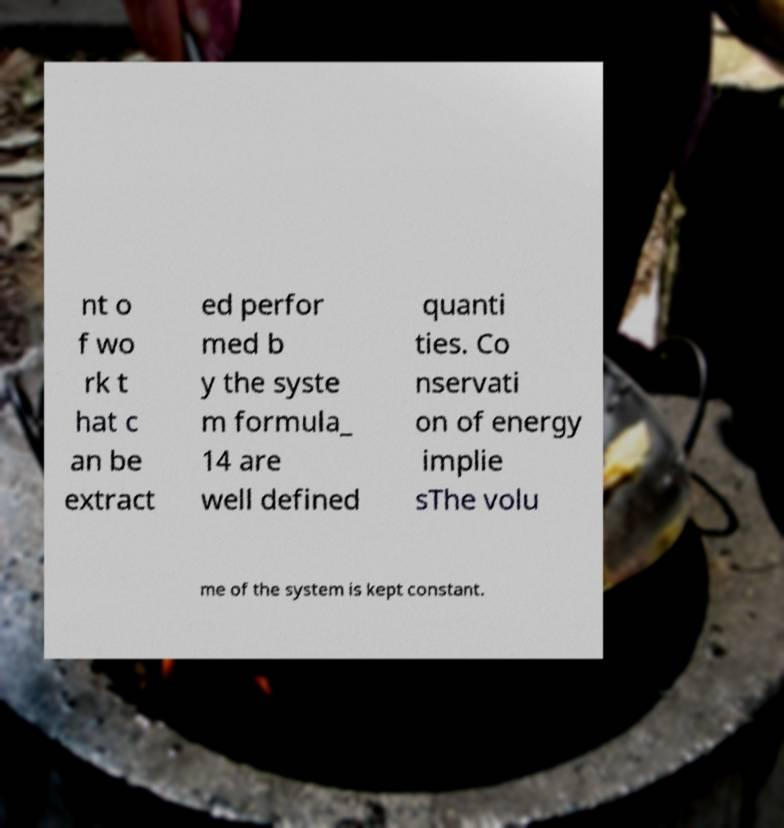Can you read and provide the text displayed in the image?This photo seems to have some interesting text. Can you extract and type it out for me? nt o f wo rk t hat c an be extract ed perfor med b y the syste m formula_ 14 are well defined quanti ties. Co nservati on of energy implie sThe volu me of the system is kept constant. 